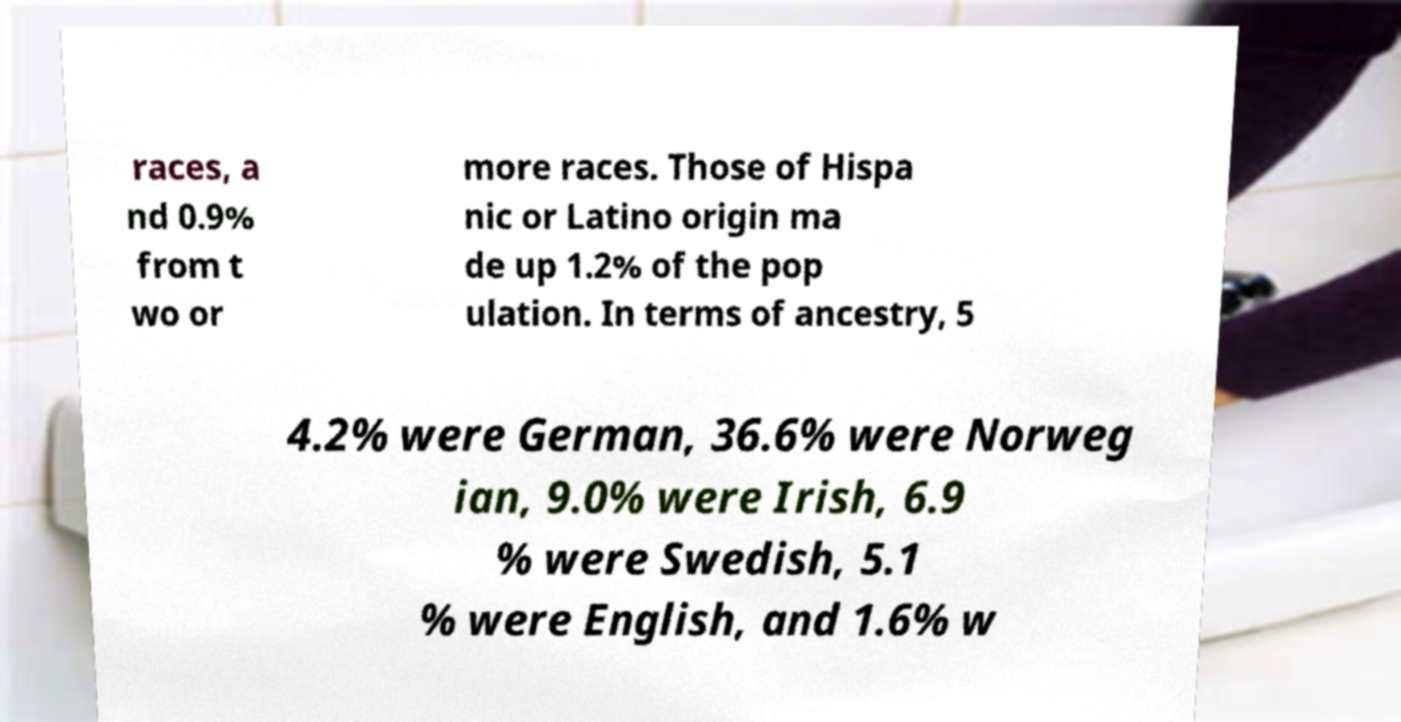Could you extract and type out the text from this image? races, a nd 0.9% from t wo or more races. Those of Hispa nic or Latino origin ma de up 1.2% of the pop ulation. In terms of ancestry, 5 4.2% were German, 36.6% were Norweg ian, 9.0% were Irish, 6.9 % were Swedish, 5.1 % were English, and 1.6% w 